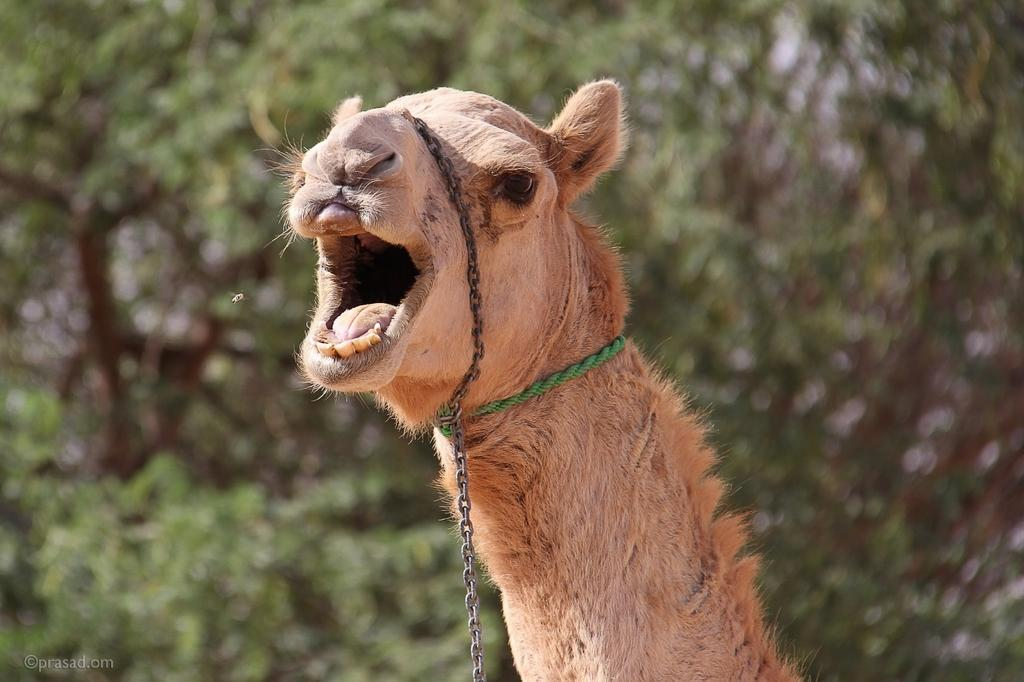What animal is present in the image? There is a camel in the image. What can be seen in the background of the image? There are trees in the background of the image. Where might this image have been taken? The image may have been taken in a zoo. What type of brain can be seen in the image? There is no brain present in the image; it features a camel and trees in the background. 